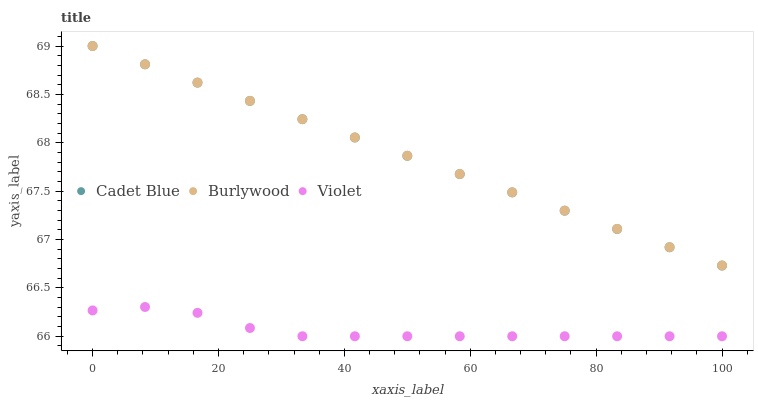Does Violet have the minimum area under the curve?
Answer yes or no. Yes. Does Burlywood have the maximum area under the curve?
Answer yes or no. Yes. Does Cadet Blue have the minimum area under the curve?
Answer yes or no. No. Does Cadet Blue have the maximum area under the curve?
Answer yes or no. No. Is Cadet Blue the smoothest?
Answer yes or no. Yes. Is Violet the roughest?
Answer yes or no. Yes. Is Violet the smoothest?
Answer yes or no. No. Is Cadet Blue the roughest?
Answer yes or no. No. Does Violet have the lowest value?
Answer yes or no. Yes. Does Cadet Blue have the lowest value?
Answer yes or no. No. Does Cadet Blue have the highest value?
Answer yes or no. Yes. Does Violet have the highest value?
Answer yes or no. No. Is Violet less than Cadet Blue?
Answer yes or no. Yes. Is Cadet Blue greater than Violet?
Answer yes or no. Yes. Does Burlywood intersect Cadet Blue?
Answer yes or no. Yes. Is Burlywood less than Cadet Blue?
Answer yes or no. No. Is Burlywood greater than Cadet Blue?
Answer yes or no. No. Does Violet intersect Cadet Blue?
Answer yes or no. No. 